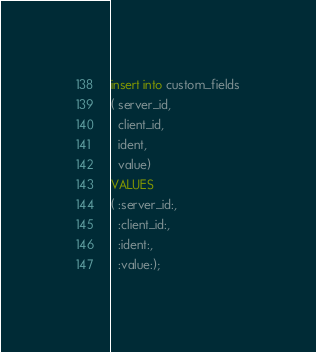<code> <loc_0><loc_0><loc_500><loc_500><_SQL_>insert into custom_fields
( server_id,
  client_id,
  ident,
  value)
VALUES 
( :server_id:,
  :client_id:,
  :ident:,
  :value:);
</code> 